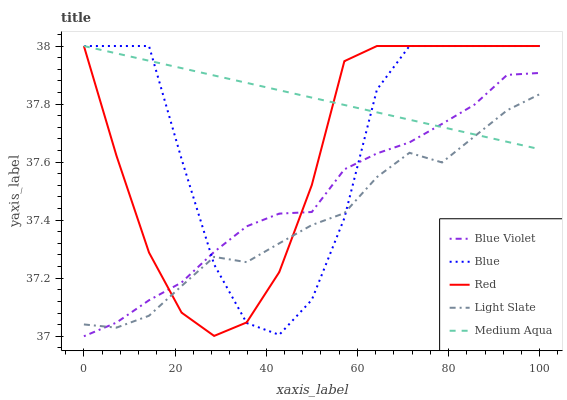Does Light Slate have the minimum area under the curve?
Answer yes or no. Yes. Does Medium Aqua have the maximum area under the curve?
Answer yes or no. Yes. Does Medium Aqua have the minimum area under the curve?
Answer yes or no. No. Does Light Slate have the maximum area under the curve?
Answer yes or no. No. Is Medium Aqua the smoothest?
Answer yes or no. Yes. Is Blue the roughest?
Answer yes or no. Yes. Is Light Slate the smoothest?
Answer yes or no. No. Is Light Slate the roughest?
Answer yes or no. No. Does Blue Violet have the lowest value?
Answer yes or no. Yes. Does Light Slate have the lowest value?
Answer yes or no. No. Does Red have the highest value?
Answer yes or no. Yes. Does Light Slate have the highest value?
Answer yes or no. No. Does Blue Violet intersect Red?
Answer yes or no. Yes. Is Blue Violet less than Red?
Answer yes or no. No. Is Blue Violet greater than Red?
Answer yes or no. No. 